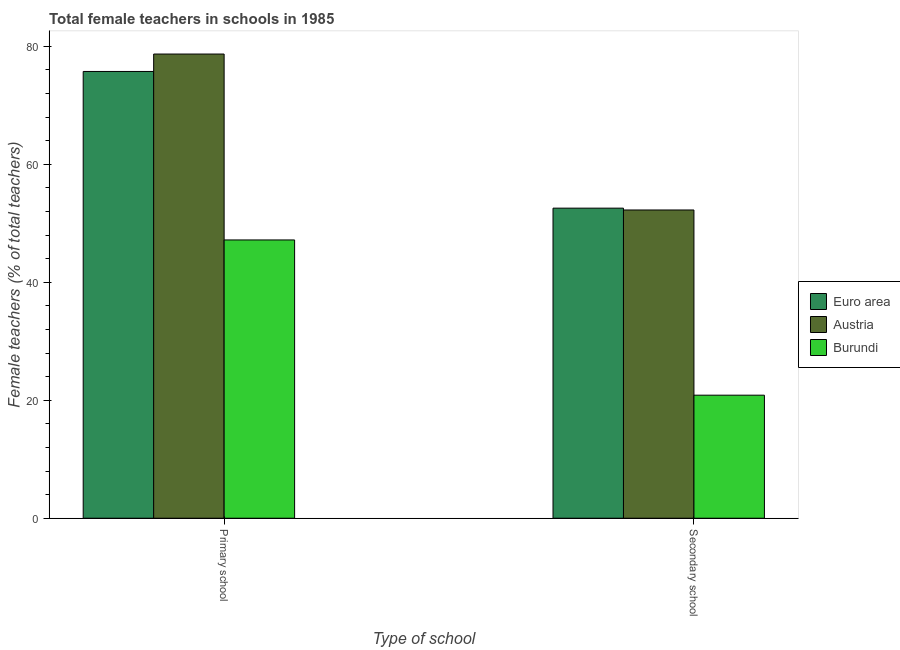How many different coloured bars are there?
Your response must be concise. 3. Are the number of bars per tick equal to the number of legend labels?
Offer a terse response. Yes. How many bars are there on the 2nd tick from the right?
Your answer should be very brief. 3. What is the label of the 2nd group of bars from the left?
Provide a short and direct response. Secondary school. What is the percentage of female teachers in secondary schools in Burundi?
Keep it short and to the point. 20.86. Across all countries, what is the maximum percentage of female teachers in secondary schools?
Your response must be concise. 52.57. Across all countries, what is the minimum percentage of female teachers in primary schools?
Offer a terse response. 47.18. In which country was the percentage of female teachers in primary schools minimum?
Your answer should be very brief. Burundi. What is the total percentage of female teachers in secondary schools in the graph?
Provide a short and direct response. 125.7. What is the difference between the percentage of female teachers in secondary schools in Euro area and that in Burundi?
Offer a very short reply. 31.71. What is the difference between the percentage of female teachers in secondary schools in Euro area and the percentage of female teachers in primary schools in Austria?
Your answer should be compact. -26.13. What is the average percentage of female teachers in secondary schools per country?
Give a very brief answer. 41.9. What is the difference between the percentage of female teachers in secondary schools and percentage of female teachers in primary schools in Euro area?
Your answer should be compact. -23.18. In how many countries, is the percentage of female teachers in secondary schools greater than 32 %?
Ensure brevity in your answer.  2. What is the ratio of the percentage of female teachers in primary schools in Austria to that in Burundi?
Make the answer very short. 1.67. Is the percentage of female teachers in primary schools in Burundi less than that in Euro area?
Provide a short and direct response. Yes. What does the 2nd bar from the left in Primary school represents?
Your answer should be compact. Austria. What does the 2nd bar from the right in Primary school represents?
Offer a terse response. Austria. How many countries are there in the graph?
Your answer should be compact. 3. Are the values on the major ticks of Y-axis written in scientific E-notation?
Keep it short and to the point. No. How many legend labels are there?
Offer a terse response. 3. What is the title of the graph?
Ensure brevity in your answer.  Total female teachers in schools in 1985. Does "Russian Federation" appear as one of the legend labels in the graph?
Offer a very short reply. No. What is the label or title of the X-axis?
Give a very brief answer. Type of school. What is the label or title of the Y-axis?
Your response must be concise. Female teachers (% of total teachers). What is the Female teachers (% of total teachers) in Euro area in Primary school?
Give a very brief answer. 75.75. What is the Female teachers (% of total teachers) of Austria in Primary school?
Ensure brevity in your answer.  78.7. What is the Female teachers (% of total teachers) of Burundi in Primary school?
Ensure brevity in your answer.  47.18. What is the Female teachers (% of total teachers) in Euro area in Secondary school?
Provide a succinct answer. 52.57. What is the Female teachers (% of total teachers) in Austria in Secondary school?
Your answer should be compact. 52.26. What is the Female teachers (% of total teachers) in Burundi in Secondary school?
Make the answer very short. 20.86. Across all Type of school, what is the maximum Female teachers (% of total teachers) in Euro area?
Offer a very short reply. 75.75. Across all Type of school, what is the maximum Female teachers (% of total teachers) of Austria?
Keep it short and to the point. 78.7. Across all Type of school, what is the maximum Female teachers (% of total teachers) of Burundi?
Your answer should be very brief. 47.18. Across all Type of school, what is the minimum Female teachers (% of total teachers) of Euro area?
Your response must be concise. 52.57. Across all Type of school, what is the minimum Female teachers (% of total teachers) of Austria?
Make the answer very short. 52.26. Across all Type of school, what is the minimum Female teachers (% of total teachers) of Burundi?
Your response must be concise. 20.86. What is the total Female teachers (% of total teachers) in Euro area in the graph?
Provide a succinct answer. 128.33. What is the total Female teachers (% of total teachers) of Austria in the graph?
Your answer should be very brief. 130.97. What is the total Female teachers (% of total teachers) of Burundi in the graph?
Offer a terse response. 68.05. What is the difference between the Female teachers (% of total teachers) of Euro area in Primary school and that in Secondary school?
Provide a short and direct response. 23.18. What is the difference between the Female teachers (% of total teachers) in Austria in Primary school and that in Secondary school?
Your answer should be compact. 26.44. What is the difference between the Female teachers (% of total teachers) of Burundi in Primary school and that in Secondary school?
Your response must be concise. 26.32. What is the difference between the Female teachers (% of total teachers) in Euro area in Primary school and the Female teachers (% of total teachers) in Austria in Secondary school?
Your answer should be very brief. 23.49. What is the difference between the Female teachers (% of total teachers) of Euro area in Primary school and the Female teachers (% of total teachers) of Burundi in Secondary school?
Your answer should be very brief. 54.89. What is the difference between the Female teachers (% of total teachers) of Austria in Primary school and the Female teachers (% of total teachers) of Burundi in Secondary school?
Provide a short and direct response. 57.84. What is the average Female teachers (% of total teachers) in Euro area per Type of school?
Make the answer very short. 64.16. What is the average Female teachers (% of total teachers) of Austria per Type of school?
Give a very brief answer. 65.48. What is the average Female teachers (% of total teachers) of Burundi per Type of school?
Provide a succinct answer. 34.02. What is the difference between the Female teachers (% of total teachers) of Euro area and Female teachers (% of total teachers) of Austria in Primary school?
Your answer should be compact. -2.95. What is the difference between the Female teachers (% of total teachers) in Euro area and Female teachers (% of total teachers) in Burundi in Primary school?
Offer a terse response. 28.57. What is the difference between the Female teachers (% of total teachers) in Austria and Female teachers (% of total teachers) in Burundi in Primary school?
Ensure brevity in your answer.  31.52. What is the difference between the Female teachers (% of total teachers) in Euro area and Female teachers (% of total teachers) in Austria in Secondary school?
Keep it short and to the point. 0.31. What is the difference between the Female teachers (% of total teachers) in Euro area and Female teachers (% of total teachers) in Burundi in Secondary school?
Provide a succinct answer. 31.71. What is the difference between the Female teachers (% of total teachers) of Austria and Female teachers (% of total teachers) of Burundi in Secondary school?
Provide a short and direct response. 31.4. What is the ratio of the Female teachers (% of total teachers) of Euro area in Primary school to that in Secondary school?
Make the answer very short. 1.44. What is the ratio of the Female teachers (% of total teachers) in Austria in Primary school to that in Secondary school?
Offer a terse response. 1.51. What is the ratio of the Female teachers (% of total teachers) of Burundi in Primary school to that in Secondary school?
Ensure brevity in your answer.  2.26. What is the difference between the highest and the second highest Female teachers (% of total teachers) of Euro area?
Your response must be concise. 23.18. What is the difference between the highest and the second highest Female teachers (% of total teachers) of Austria?
Keep it short and to the point. 26.44. What is the difference between the highest and the second highest Female teachers (% of total teachers) of Burundi?
Keep it short and to the point. 26.32. What is the difference between the highest and the lowest Female teachers (% of total teachers) in Euro area?
Give a very brief answer. 23.18. What is the difference between the highest and the lowest Female teachers (% of total teachers) of Austria?
Make the answer very short. 26.44. What is the difference between the highest and the lowest Female teachers (% of total teachers) in Burundi?
Provide a short and direct response. 26.32. 